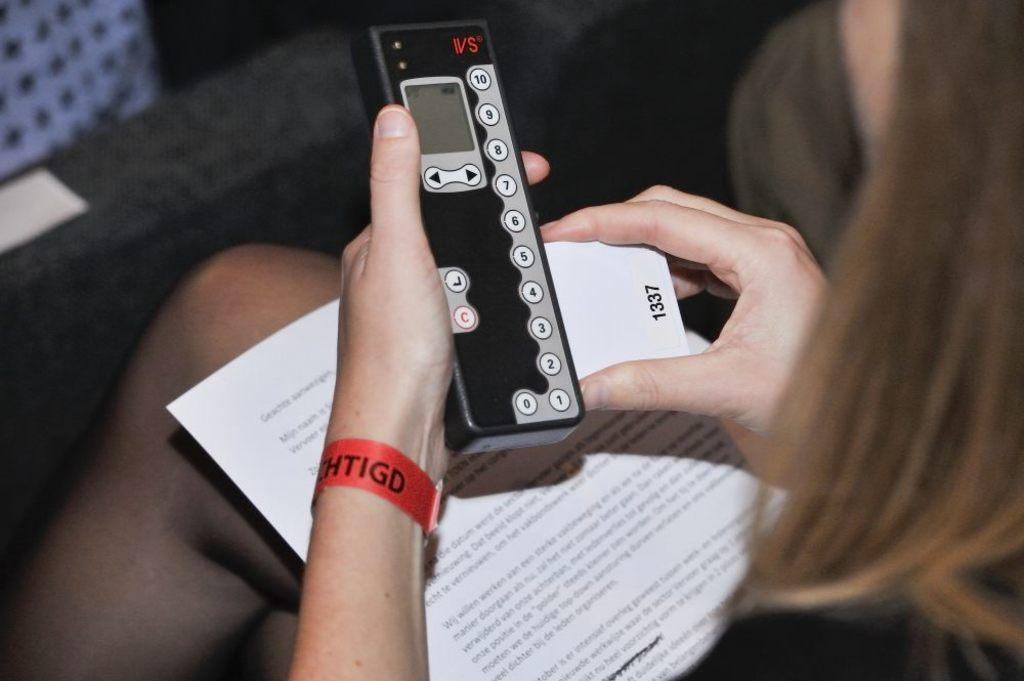Who is the main subject in the picture? A: There is a girl in the picture. What is the girl doing in the picture? The girl is sitting on a chair. What else can be seen in the picture besides the girl? There is a white paper and a black remote in the picture. What is the girl holding in her hand? The girl is holding a black remote in her hand. How many fingers are visible on the girl's hand holding the crack in the camp? There is no mention of fingers, crack, or camp in the image. The girl is holding a black remote, and there is a white paper in the picture. 